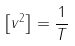Convert formula to latex. <formula><loc_0><loc_0><loc_500><loc_500>\left [ v ^ { 2 } \right ] = \frac { 1 } { T }</formula> 